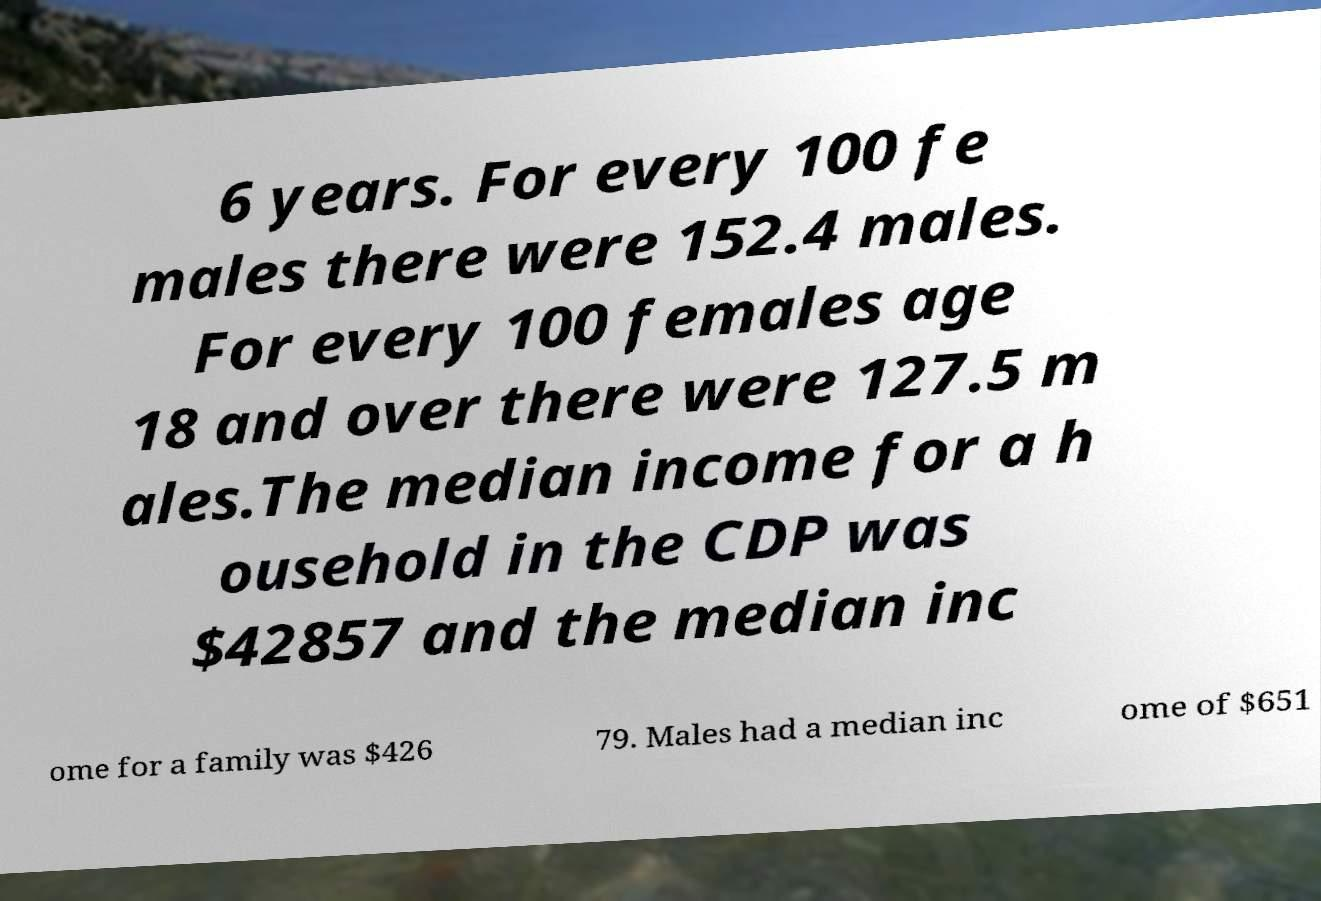Could you extract and type out the text from this image? 6 years. For every 100 fe males there were 152.4 males. For every 100 females age 18 and over there were 127.5 m ales.The median income for a h ousehold in the CDP was $42857 and the median inc ome for a family was $426 79. Males had a median inc ome of $651 